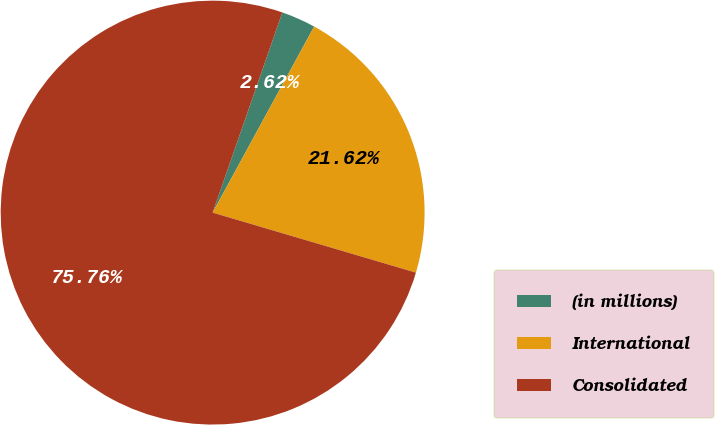Convert chart to OTSL. <chart><loc_0><loc_0><loc_500><loc_500><pie_chart><fcel>(in millions)<fcel>International<fcel>Consolidated<nl><fcel>2.62%<fcel>21.62%<fcel>75.76%<nl></chart> 